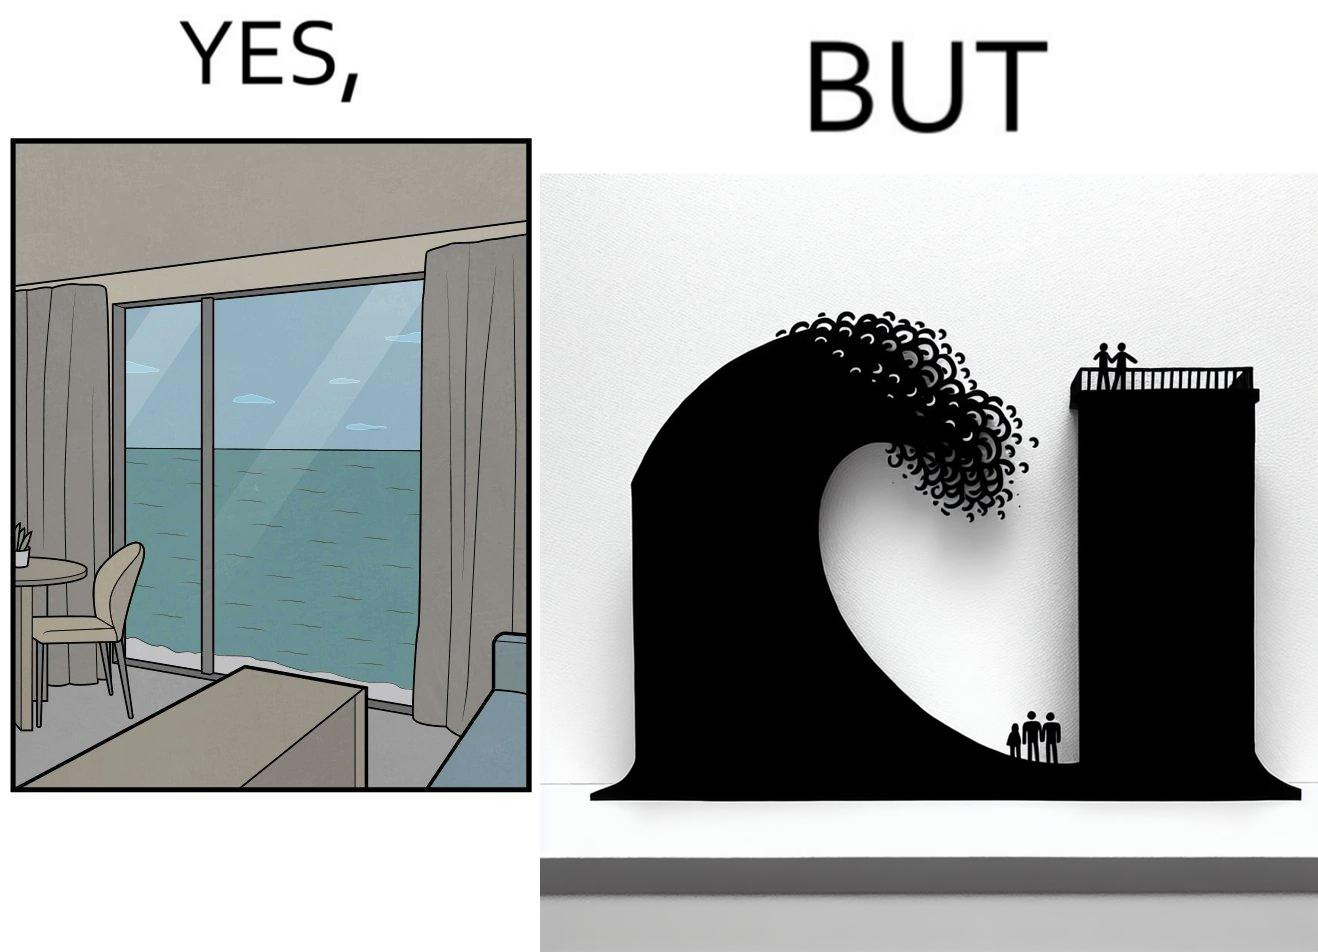Compare the left and right sides of this image. In the left part of the image: a room with a sea-facing door In the right part of the image: high waves in the sea twice of the height of the building near the sea 